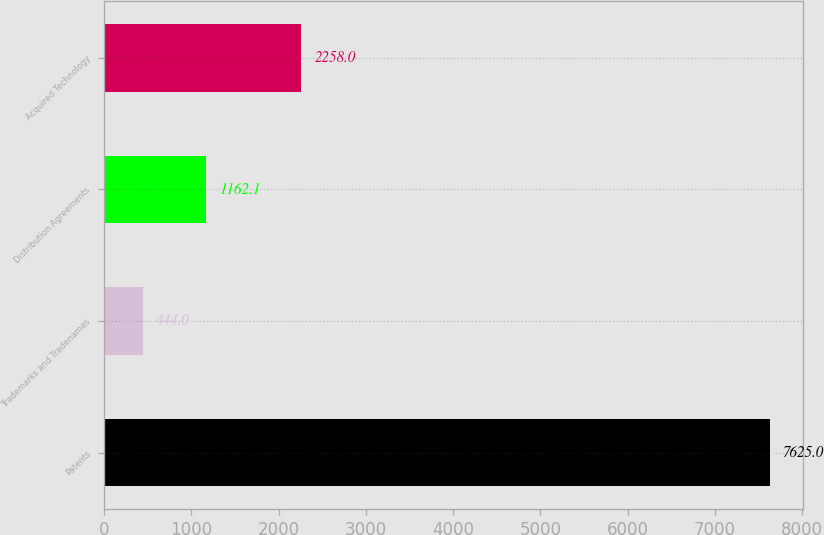Convert chart to OTSL. <chart><loc_0><loc_0><loc_500><loc_500><bar_chart><fcel>Patents<fcel>Trademarks and Tradenames<fcel>Distribution Agreements<fcel>Acquired Technology<nl><fcel>7625<fcel>444<fcel>1162.1<fcel>2258<nl></chart> 